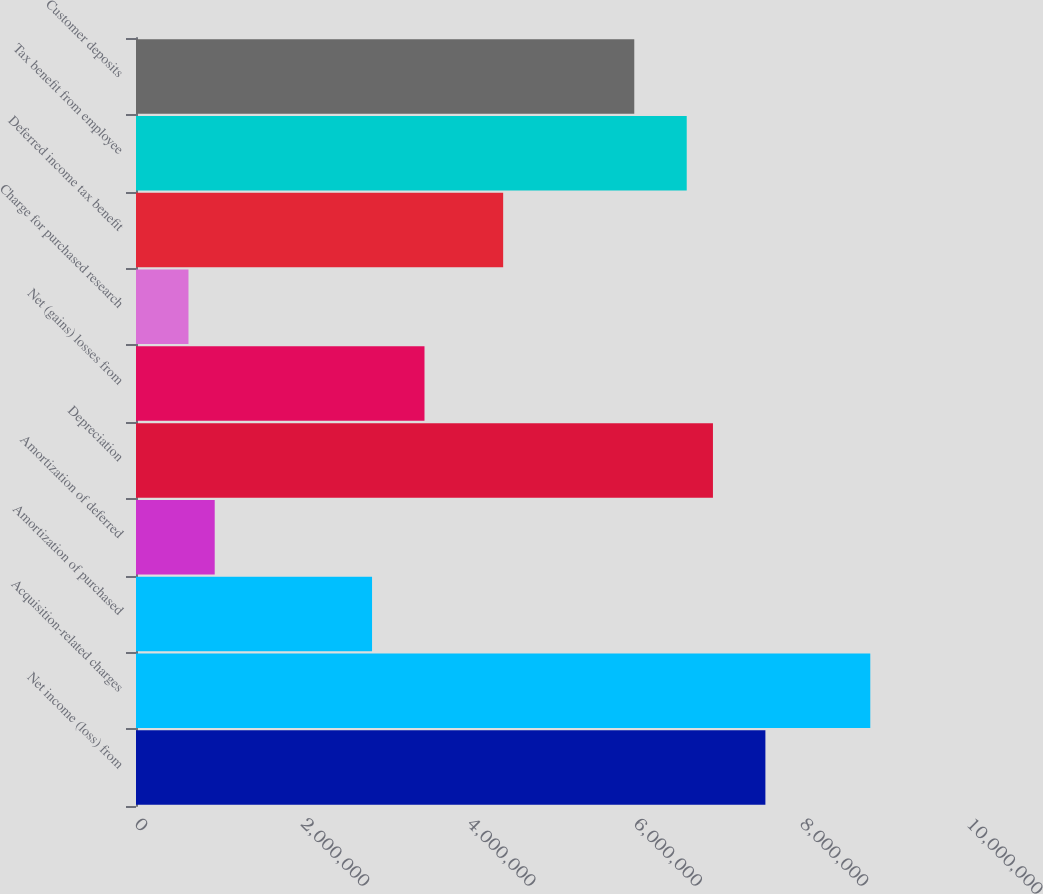Convert chart. <chart><loc_0><loc_0><loc_500><loc_500><bar_chart><fcel>Net income (loss) from<fcel>Acquisition-related charges<fcel>Amortization of purchased<fcel>Amortization of deferred<fcel>Depreciation<fcel>Net (gains) losses from<fcel>Charge for purchased research<fcel>Deferred income tax benefit<fcel>Tax benefit from employee<fcel>Customer deposits<nl><fcel>7.56481e+06<fcel>8.82554e+06<fcel>2.83707e+06<fcel>945978<fcel>6.93445e+06<fcel>3.46744e+06<fcel>630795<fcel>4.41299e+06<fcel>6.61926e+06<fcel>5.9889e+06<nl></chart> 